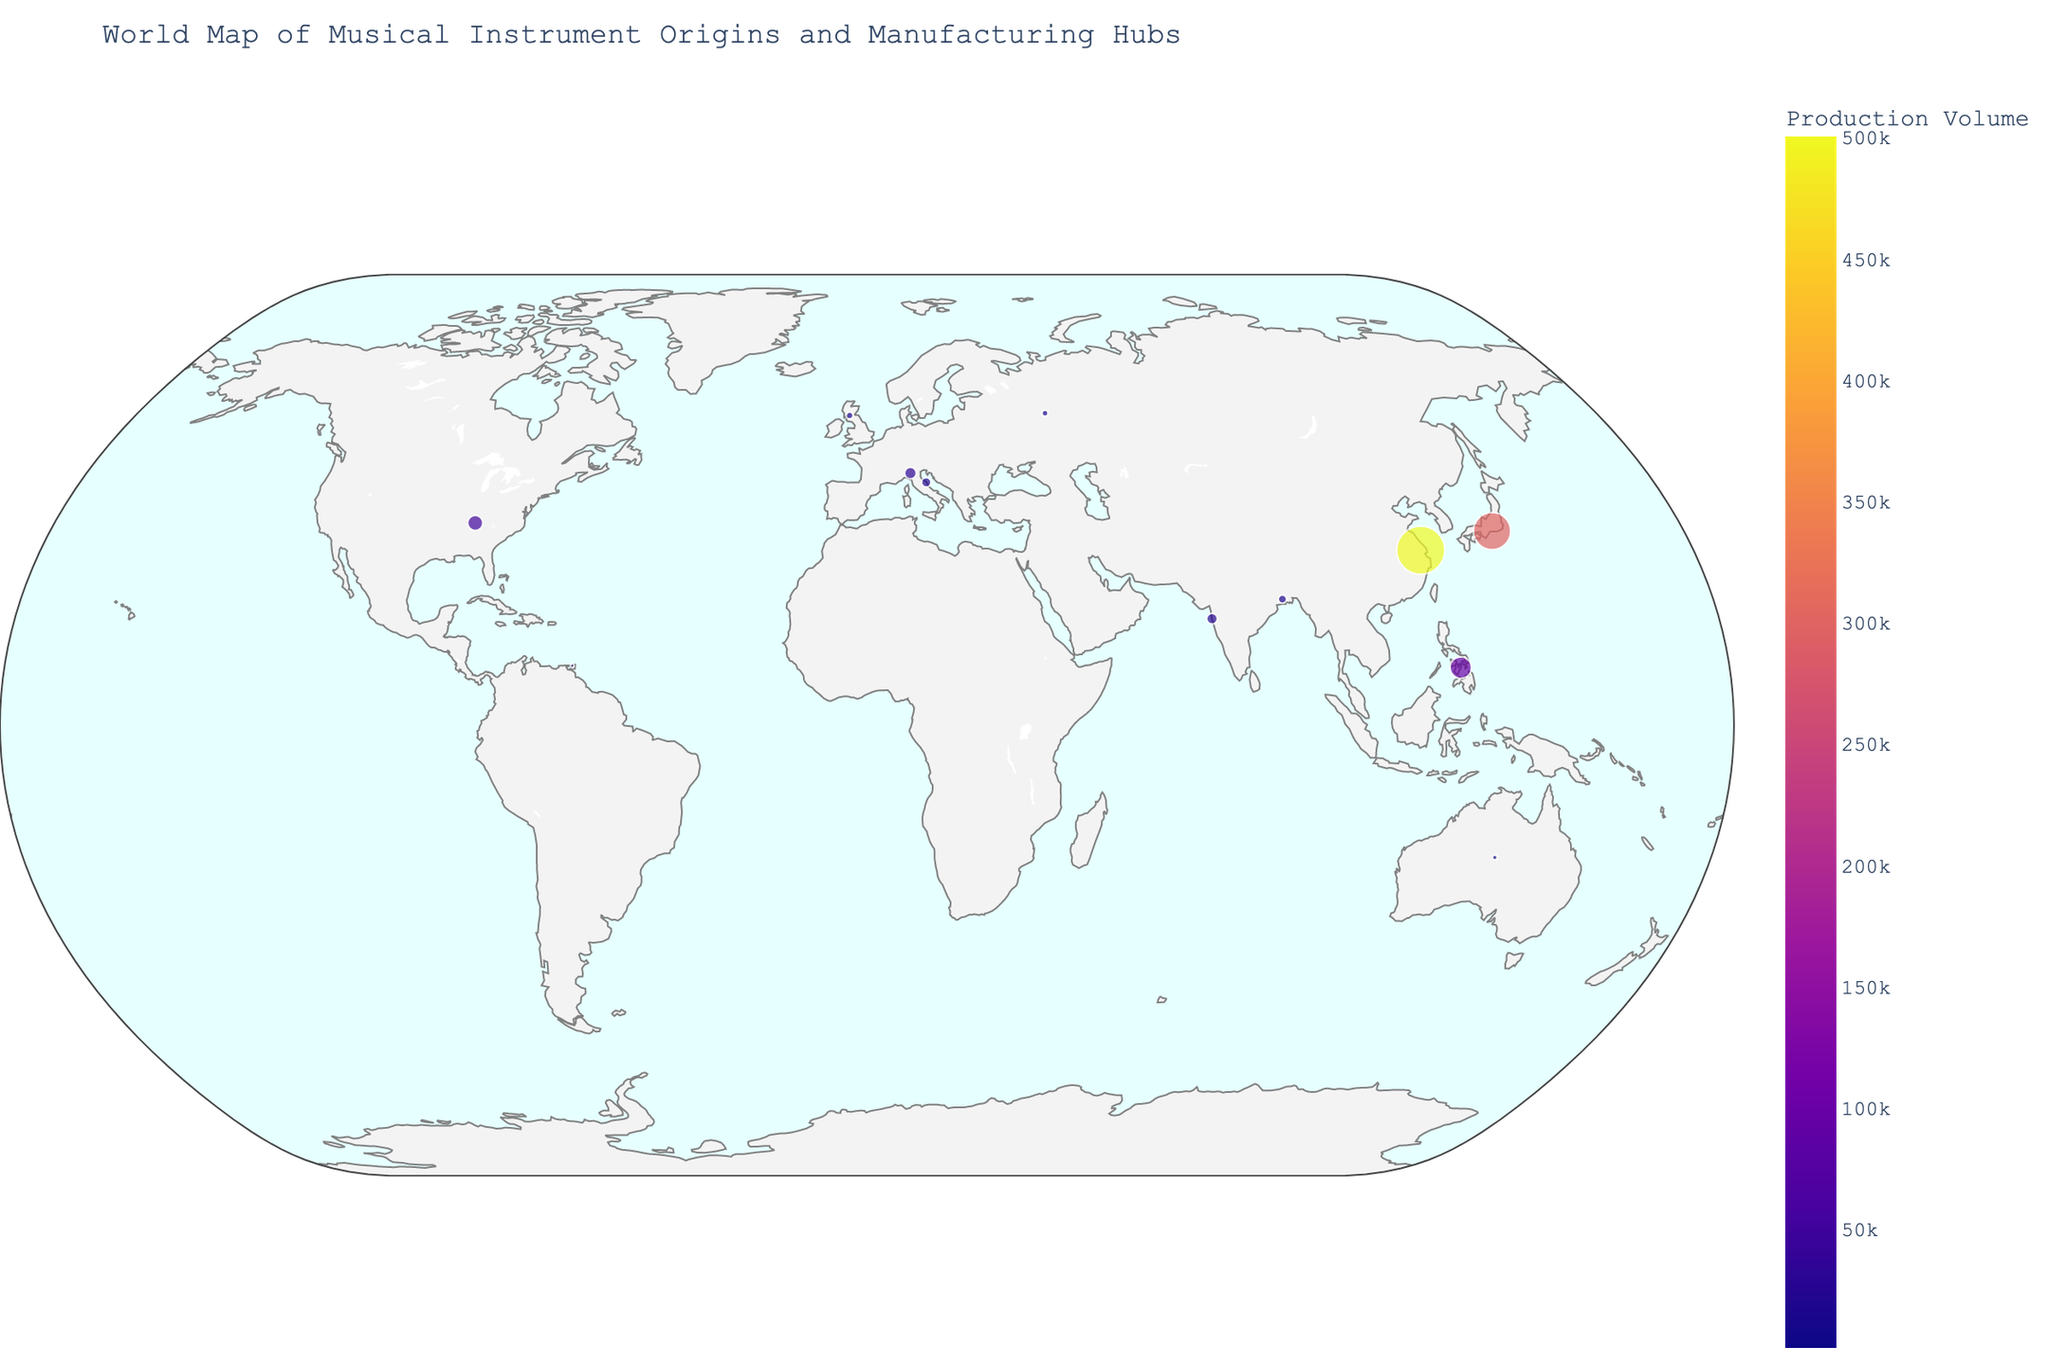What is the title of the plot? The title is usually displayed prominently at the top of the figure, providing context for what the plot represents. Based on the figure, the title is "World Map of Musical Instrument Origins and Manufacturing Hubs".
Answer: World Map of Musical Instrument Origins and Manufacturing Hubs Which instrument has the highest production volume and where is it manufactured? Looking at the size and color of the points in the plot, the one with the largest size and most intense color represents the highest production volume. That instrument is the Guitar, manufactured in Suzhou, China.
Answer: Guitar in Suzhou, China How many instruments have their origins in Italy? Checking the plot for points with the origin label 'Italy', we find there are three instruments: Piano, Violin, and Accordion.
Answer: Three For instruments originating in India, which has the larger production volume, Tabla or Sitar? Comparing the sizes and colors of the points associated with Tabla (Mumbai) and Sitar (Kolkata), the one with larger size and more intense color is Tabla, indicating a larger production volume.
Answer: Tabla Which instrument originating from Russia has the lowest production volume and where is it manufactured? By finding the points related to Russia, we see two instruments: Balalaika and Theremin. The point with lower production volume, indicated by its smaller size and lighter color, is for Theremin, manufactured in Asheville, USA.
Answer: Theremin in Asheville, USA What is the combined production volume of musical instruments originating from Australia and Trinidad and Tobago? The production volume for Didgeridoo (Australia) is 5000, and for Steel Drum (Trinidad and Tobago) is 3000. Adding these values gives us the total production volume. 5000 + 3000 = 8000.
Answer: 8000 Which instrument manufactured in the Philippines is shown in the plot, and what is its origin? Looking for a point with the manufacturing hub in the Philippines, we identify the Ukulele. The origin of the Ukulele is Hawaii.
Answer: Ukulele from Hawaii Are there any instruments that are manufactured in the same country as their origin? Checking the plot for instruments where the origin and manufacturing hub are the same, we find three matches: Balalaika in Russia, Violin in Italy, and Didgeridoo in Australia.
Answer: Three What trends can you observe about the location of modern-day manufacturing hubs for different musical instruments? Observing the plot, a trend evident is that many instruments are now manufactured in Asia, regardless of their origin. For example, Guitar in China, Piano in Japan, and Ukulele in the Philippines.
Answer: Many instruments are now manufactured in Asia Which musical instrument has its manufacturing hub closest to its origin? By comparing the distance between the origin and its manufacturing hub for all instruments in the plot, Violin (manufactured in Cremona, Italy, which is in the same country as its origin) has its hub closest to its origin.
Answer: Violin in Cremona, Italy 